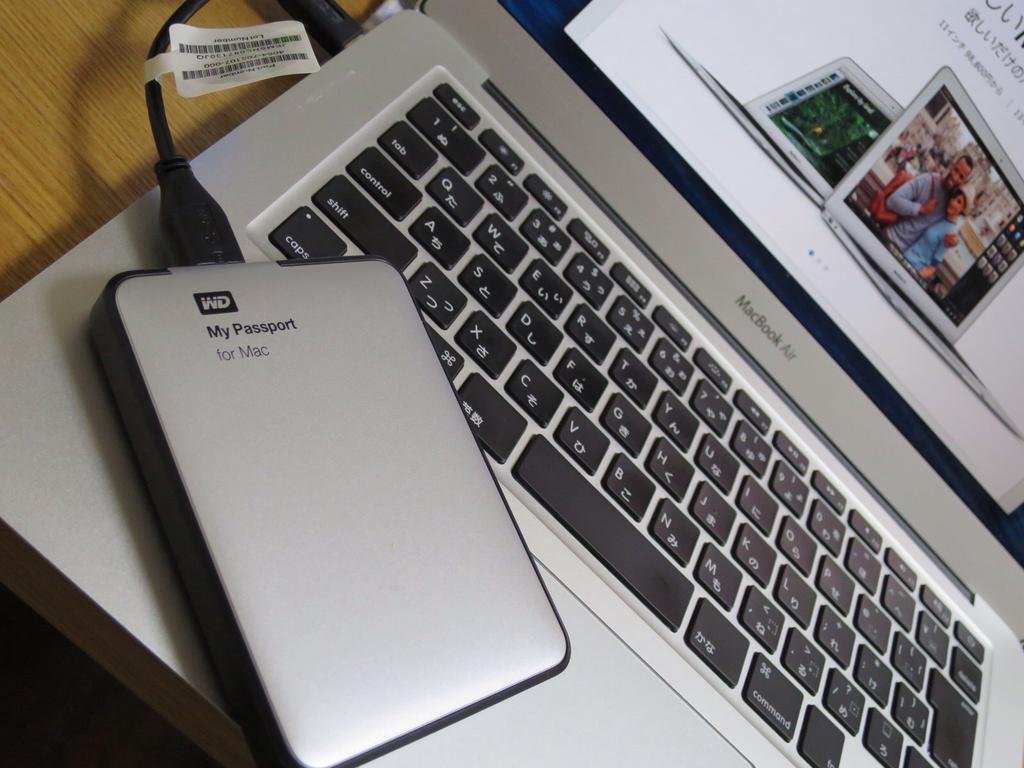Provide a one-sentence caption for the provided image. A WD My Passport for Mac device hooked up to a gray MacBook Air. 